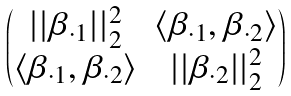<formula> <loc_0><loc_0><loc_500><loc_500>\begin{pmatrix} | | \beta _ { \cdot 1 } | | _ { 2 } ^ { 2 } & \langle \beta _ { \cdot 1 } , \beta _ { \cdot 2 } \rangle \\ \langle \beta _ { \cdot 1 } , \beta _ { \cdot 2 } \rangle & | | \beta _ { \cdot 2 } | | _ { 2 } ^ { 2 } \end{pmatrix}</formula> 